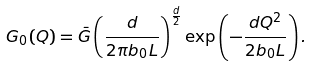<formula> <loc_0><loc_0><loc_500><loc_500>G _ { 0 } ( { Q } ) = \bar { G } \left ( \frac { d } { 2 \pi b _ { 0 } L } \right ) ^ { \frac { d } { 2 } } \exp \left ( - \frac { d Q ^ { 2 } } { 2 b _ { 0 } L } \right ) .</formula> 